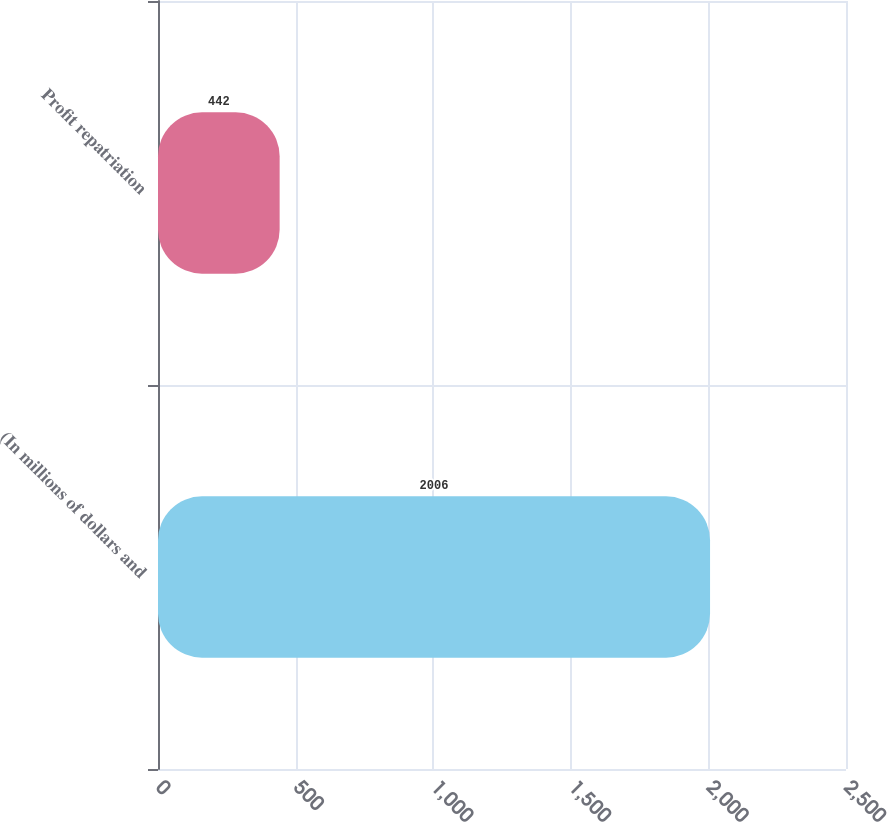Convert chart to OTSL. <chart><loc_0><loc_0><loc_500><loc_500><bar_chart><fcel>(In millions of dollars and<fcel>Profit repatriation<nl><fcel>2006<fcel>442<nl></chart> 